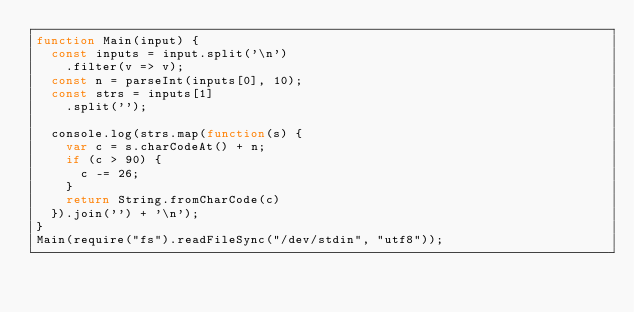Convert code to text. <code><loc_0><loc_0><loc_500><loc_500><_JavaScript_>function Main(input) {
  const inputs = input.split('\n')
    .filter(v => v);
  const n = parseInt(inputs[0], 10);
  const strs = inputs[1]
    .split('');
  
  console.log(strs.map(function(s) {
    var c = s.charCodeAt() + n;
    if (c > 90) {
      c -= 26;
    }
    return String.fromCharCode(c)
  }).join('') + '\n');
}
Main(require("fs").readFileSync("/dev/stdin", "utf8"));</code> 